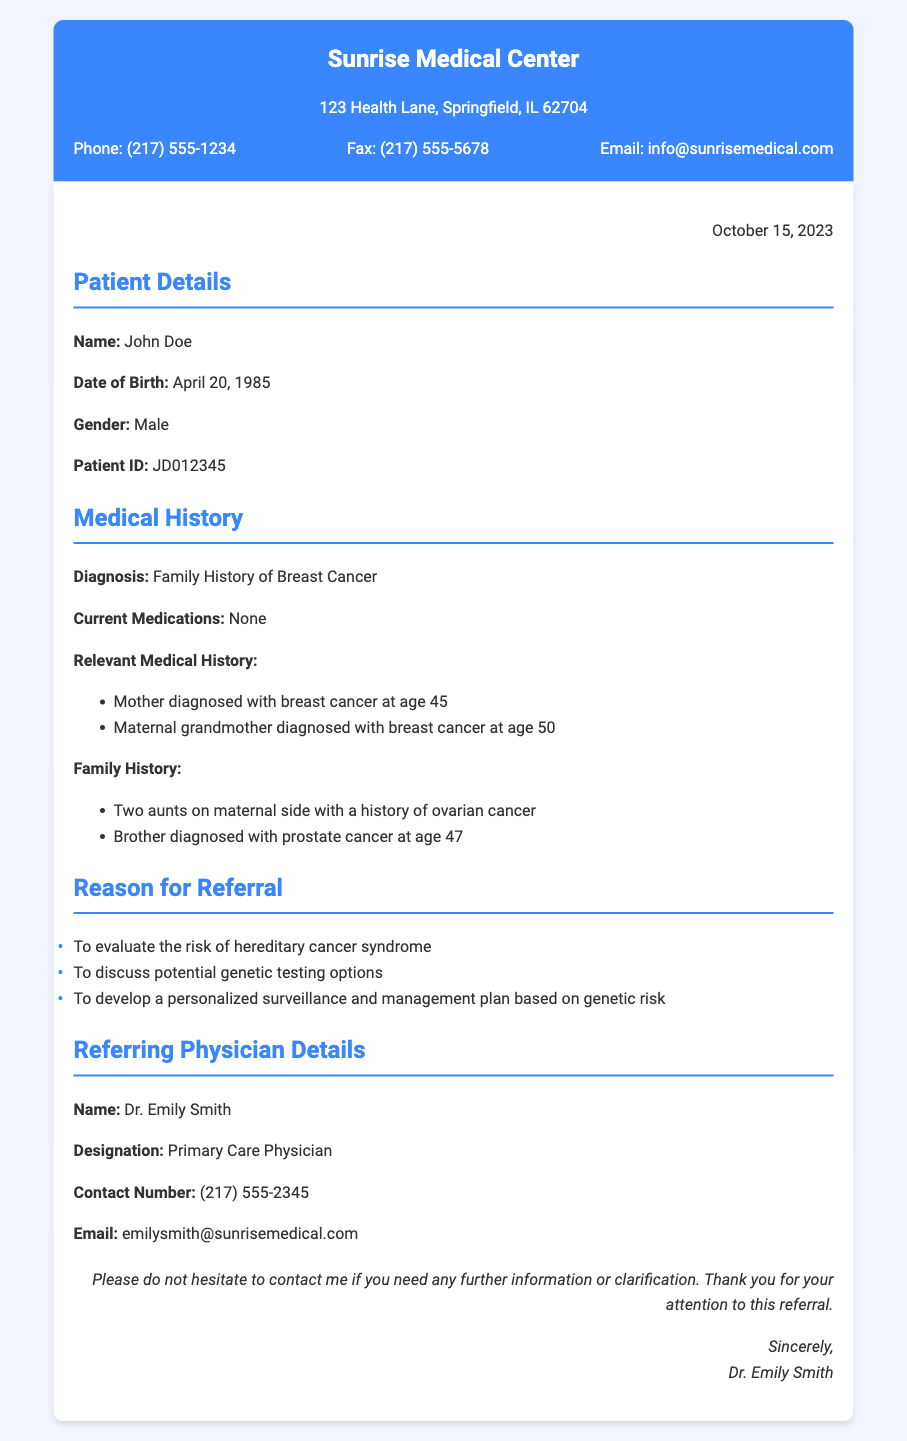what is the name of the patient? The document states that the patient's name is John Doe.
Answer: John Doe what is the patient's date of birth? The document provides the patient's date of birth as April 20, 1985.
Answer: April 20, 1985 who is the referring physician? The document lists Dr. Emily Smith as the referring physician.
Answer: Dr. Emily Smith what is the reason for the referral related to hereditary cancer? The document mentions that one of the reasons for the referral is to evaluate the risk of hereditary cancer syndrome.
Answer: evaluate the risk of hereditary cancer syndrome how many family members have been diagnosed with breast cancer? The document indicates that the patient has two family members diagnosed with breast cancer, his mother and maternal grandmother.
Answer: two what is the contact number of the referring physician? The document states that the referring physician's contact number is (217) 555-2345.
Answer: (217) 555-2345 on what date was the letter written? The letter was written on October 15, 2023, as noted in the document.
Answer: October 15, 2023 what is the patient's gender? The document specifies that the patient's gender is Male.
Answer: Male how many aunts on the maternal side have a history of ovarian cancer? The document states that there are two aunts on the maternal side with a history of ovarian cancer.
Answer: two 